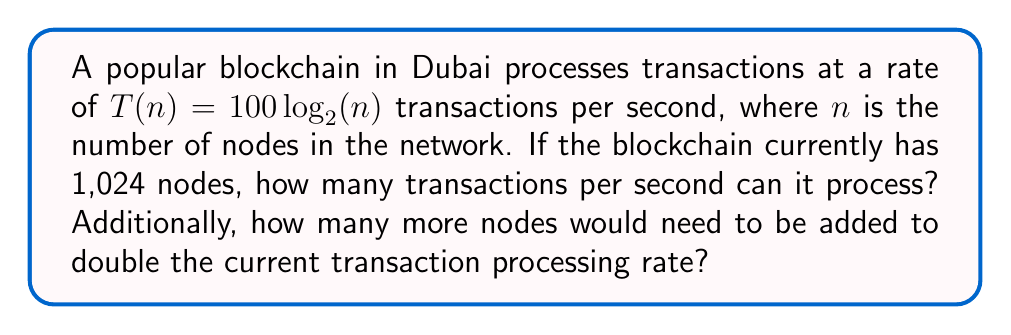Can you answer this question? Let's approach this problem step-by-step:

1. Current transaction rate:
   We're given that $T(n) = 100 \log_2(n)$ and $n = 1,024$.
   
   $$T(1024) = 100 \log_2(1024)$$
   $$= 100 \cdot 10$$ (since $2^{10} = 1024$)
   $$= 1000$$ transactions per second

2. To double the transaction rate:
   We need to find $n$ such that $T(n) = 2000$ transactions per second.
   
   $$2000 = 100 \log_2(n)$$
   $$20 = \log_2(n)$$
   $$2^{20} = n$$
   $$n = 1,048,576$$ nodes

3. Additional nodes needed:
   $$1,048,576 - 1,024 = 1,047,552$$ nodes

This analysis demonstrates the logarithmic scalability of blockchain transactions. While the number of nodes needs to increase exponentially (from $2^{10}$ to $2^{20}$), the transaction rate only doubles, highlighting the scalability challenges in blockchain technology.
Answer: 1000 tps; 1,047,552 nodes 